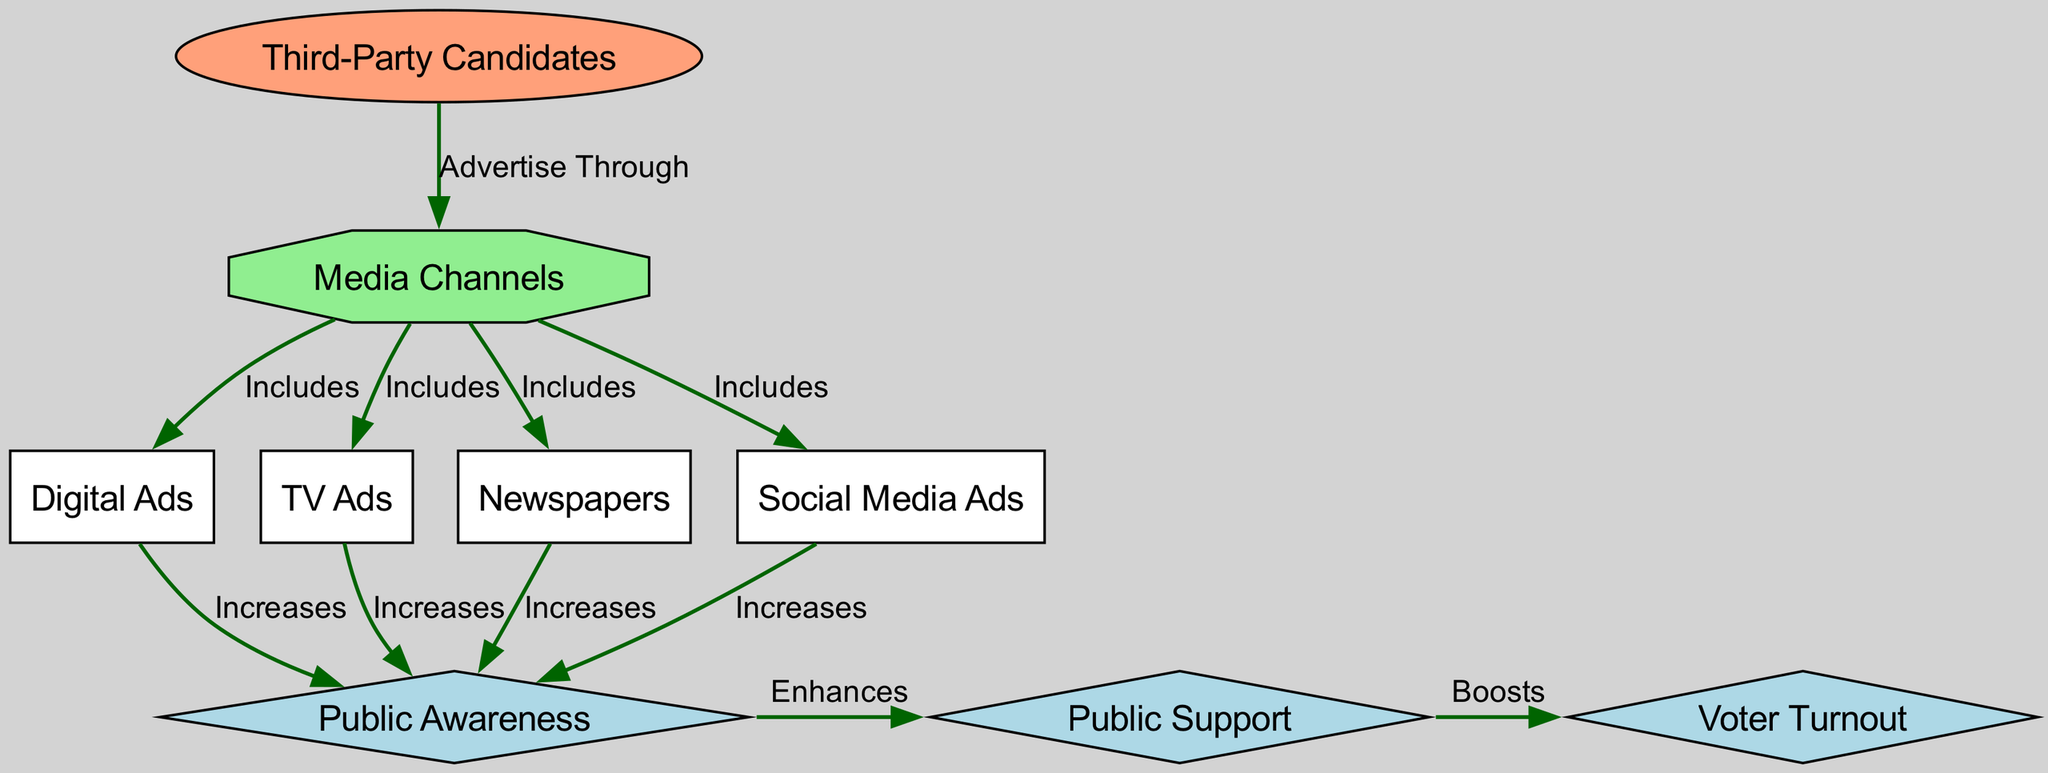What are the types of media channels available for third-party candidates? The diagram clearly lists four media channels that third-party candidates can utilize: Digital Ads, TV Ads, Newspapers, and Social Media Ads. Each of these media channels is connected to the 'media_channels' node, indicating their role in the advertising strategy.
Answer: Digital Ads, TV Ads, Newspapers, Social Media Ads How many edges are present in the diagram? By counting the connections (edges) related to the various nodes, we can see there are a total of 14 edges connecting the nodes in the diagram. Each edge represents a relationship between the nodes, with both direct and indirect connections highlighted.
Answer: 14 Which media channel is likely to have the highest impact on public awareness? The diagram indicates that Digital Ads, TV Ads, Newspapers, and Social Media Ads all have a direct connection to the Public Awareness node, marked as "Increases." However, to determine which one has the highest impact, we need to analyze external data or context on ad effectiveness; thus, we cannot definitively state which one it is based solely on the diagram.
Answer: Cannot be determined What effect do the media channels have on public support? The diagram shows that media channels influence public awareness first, which in turn enhances public support. This indicates that without their effectiveness in increasing public awareness, public support might not be significantly affected. Therefore, the media channels indirectly boost public support.
Answer: Enhances How does public support influence voter turnout? The diagram establishes a directional edge from public support to voter turnout, indicating a boosting effect. This implies that as public support increases, voter turnout is also likely to rise, establishing a cause-and-effect relationship across these concepts.
Answer: Boosts Which specific media channels contribute to increasing public awareness? The specific media channels contributing to public awareness include Digital Ads, TV Ads, Newspapers, and Social Media Ads, as each has a direct connection labeled "Increases" to the Public Awareness node in the diagram.
Answer: Digital Ads, TV Ads, Newspapers, Social Media Ads What role do campaign advertisements play in the success of third-party candidates? Campaign advertisements play a crucial role by providing a pathway through media channels that increases public awareness, which subsequently enhances public support and boosts voter turnout for third-party candidates. They are the vital mechanism driving the candidates' visibility and potential electoral success.
Answer: Important pathway Which node represents public awareness in the diagram? The node labeled "Public Awareness" is distinctly marked and represented as a diamond in the diagram, indicating its significance in the flow of campaign advertisements leading to increased public support and voter turnout.
Answer: Public Awareness What is the starting point for third-party candidates in the diagram? The starting point is marked by the node "Third-Party Candidates," which initiates the flow of influences to the media channels where the advertisements are distributed. This is the entry point for their campaign activities as illustrated in the diagram.
Answer: Third-Party Candidates 